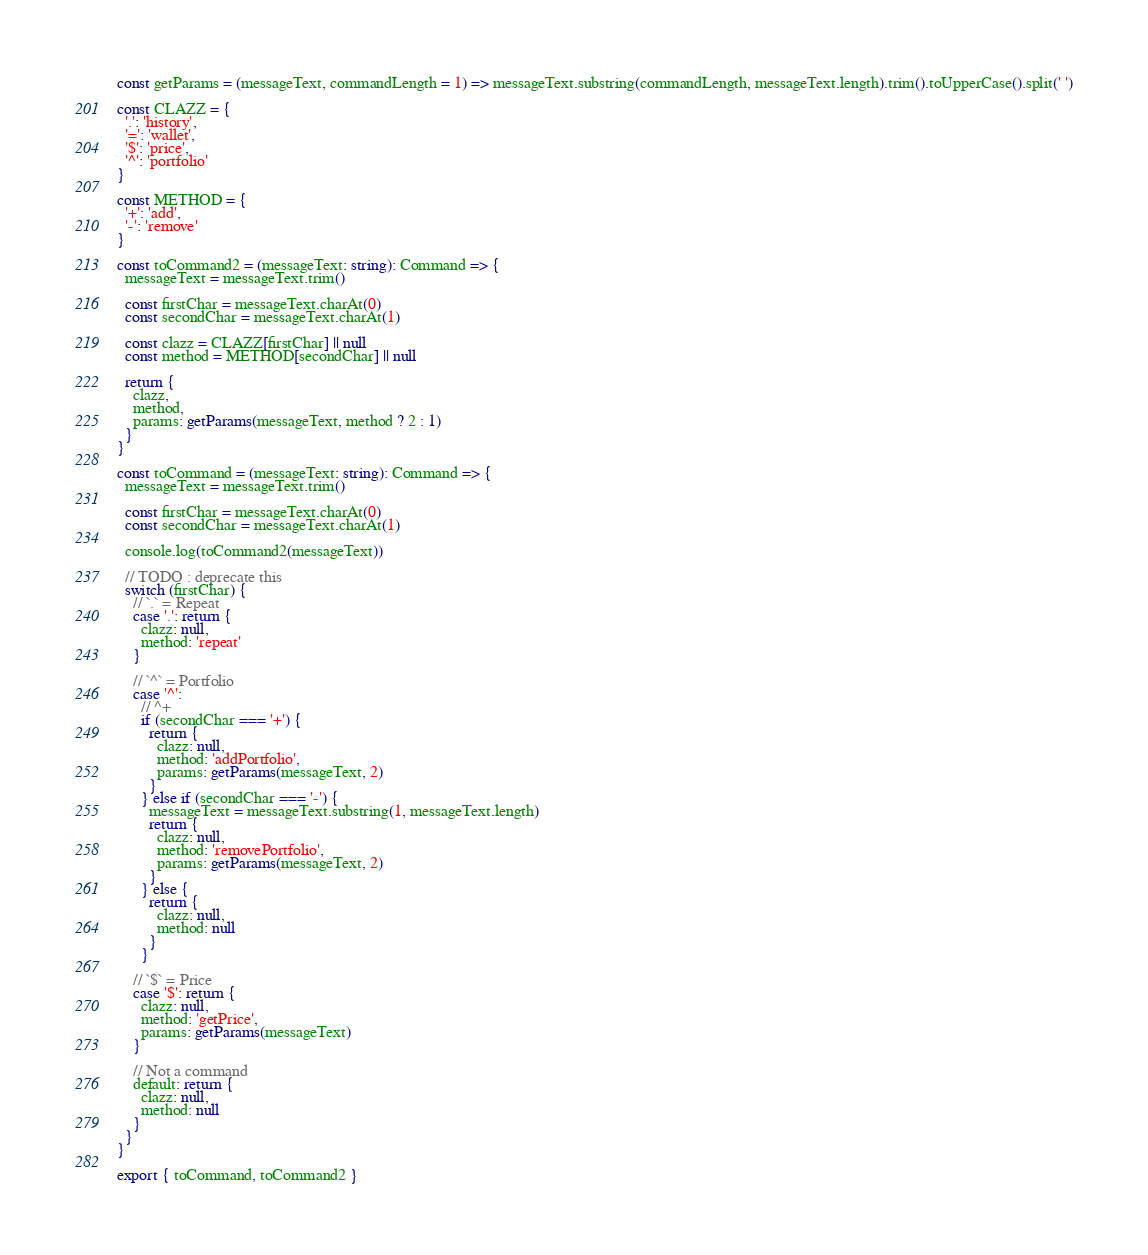Convert code to text. <code><loc_0><loc_0><loc_500><loc_500><_TypeScript_>const getParams = (messageText, commandLength = 1) => messageText.substring(commandLength, messageText.length).trim().toUpperCase().split(' ')

const CLAZZ = {
  '.': 'history',
  '=': 'wallet',
  '$': 'price',
  '^': 'portfolio'
}

const METHOD = {
  '+': 'add',
  '-': 'remove'
}

const toCommand2 = (messageText: string): Command => {
  messageText = messageText.trim()

  const firstChar = messageText.charAt(0)
  const secondChar = messageText.charAt(1)

  const clazz = CLAZZ[firstChar] || null
  const method = METHOD[secondChar] || null

  return {
    clazz,
    method,
    params: getParams(messageText, method ? 2 : 1)
  }
}

const toCommand = (messageText: string): Command => {
  messageText = messageText.trim()

  const firstChar = messageText.charAt(0)
  const secondChar = messageText.charAt(1)

  console.log(toCommand2(messageText))

  // TODO : deprecate this
  switch (firstChar) {
    // `.` = Repeat
    case '.': return {
      clazz: null,
      method: 'repeat'
    }

    // `^` = Portfolio
    case '^':
      // ^+
      if (secondChar === '+') {
        return {
          clazz: null,
          method: 'addPortfolio',
          params: getParams(messageText, 2)
        }
      } else if (secondChar === '-') {
        messageText = messageText.substring(1, messageText.length)
        return {
          clazz: null,
          method: 'removePortfolio',
          params: getParams(messageText, 2)
        }
      } else {
        return {
          clazz: null,
          method: null
        }
      }

    // `$` = Price
    case '$': return {
      clazz: null,
      method: 'getPrice',
      params: getParams(messageText)
    }

    // Not a command  
    default: return {
      clazz: null,
      method: null
    }
  }
}

export { toCommand, toCommand2 }</code> 